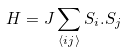<formula> <loc_0><loc_0><loc_500><loc_500>H = J \sum _ { \langle i j \rangle } { S } _ { i } . { S } _ { j }</formula> 